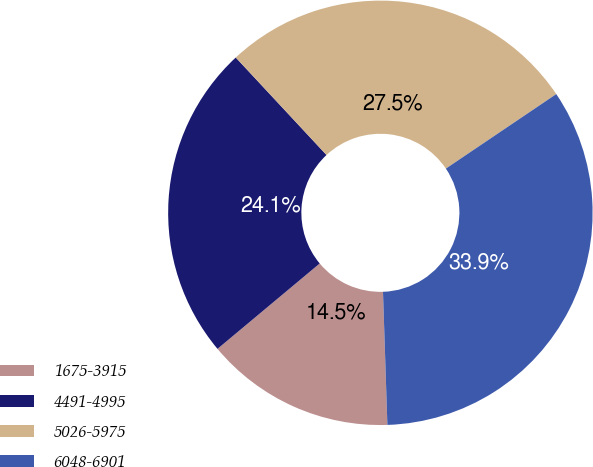<chart> <loc_0><loc_0><loc_500><loc_500><pie_chart><fcel>1675-3915<fcel>4491-4995<fcel>5026-5975<fcel>6048-6901<nl><fcel>14.45%<fcel>24.14%<fcel>27.48%<fcel>33.92%<nl></chart> 